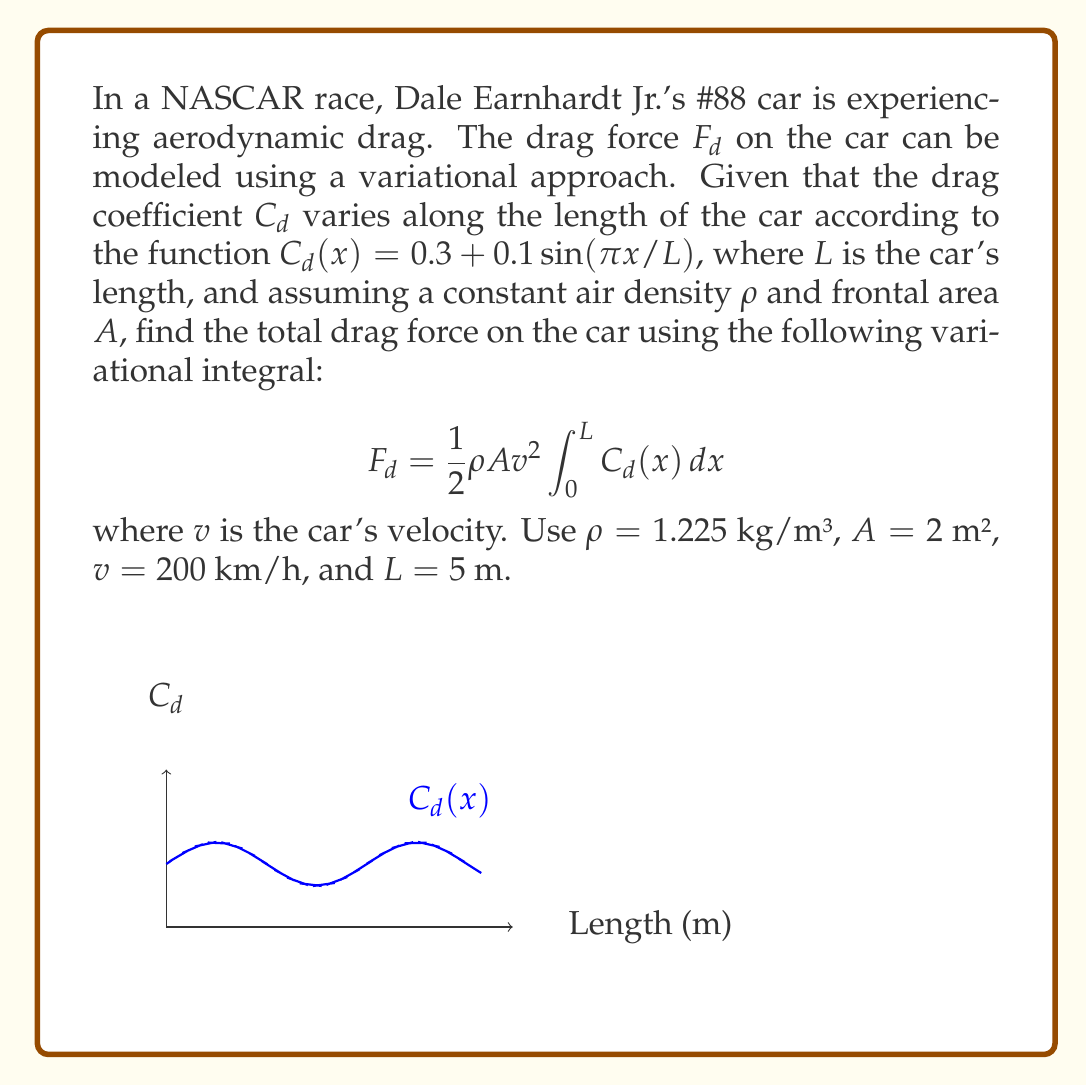Can you solve this math problem? Let's approach this step-by-step:

1) First, we need to convert the velocity to m/s:
   $v = 200$ km/h = $200 * (1000/3600)$ m/s = $55.56$ m/s

2) Now, we need to evaluate the integral of $C_d(x)$ over the length of the car:

   $$\int_0^L C_d(x) dx = \int_0^5 (0.3 + 0.1\sin(\pi x/5)) dx$$

3) We can split this into two integrals:

   $$\int_0^5 0.3 dx + \int_0^5 0.1\sin(\pi x/5) dx$$

4) The first integral is straightforward:

   $$0.3 \cdot 5 = 1.5$$

5) For the second integral, we use the substitution $u = \pi x/5$:

   $$0.1 \cdot \frac{5}{\pi} \int_0^\pi \sin(u) du = -0.1 \cdot \frac{5}{\pi} [\cos(u)]_0^\pi = -0.1 \cdot \frac{5}{\pi} (-2) = \frac{1}{\pi}$$

6) Adding the results from steps 4 and 5:

   $$\int_0^L C_d(x) dx = 1.5 + \frac{1}{\pi} \approx 1.8183$$

7) Now we can plug this into our original formula:

   $$F_d = \frac{1}{2} \cdot 1.225 \cdot 2 \cdot 55.56^2 \cdot 1.8183$$

8) Calculating this:

   $$F_d \approx 3404.7 \text{ N}$$
Answer: $3404.7$ N 